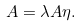Convert formula to latex. <formula><loc_0><loc_0><loc_500><loc_500>A = \lambda A \eta .</formula> 